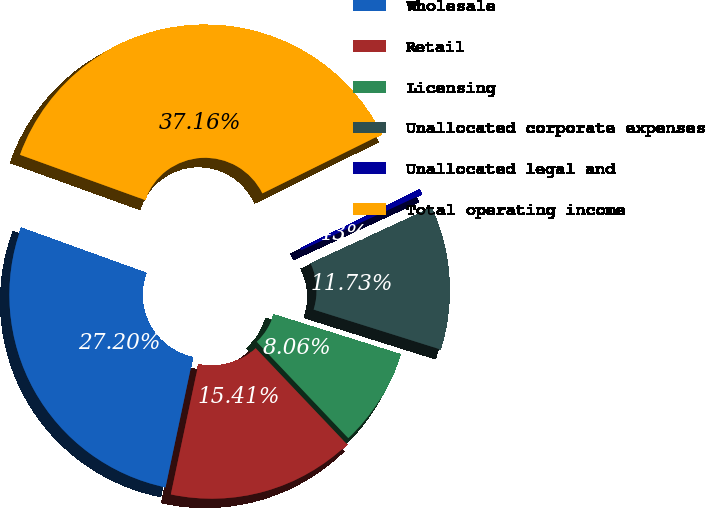Convert chart to OTSL. <chart><loc_0><loc_0><loc_500><loc_500><pie_chart><fcel>Wholesale<fcel>Retail<fcel>Licensing<fcel>Unallocated corporate expenses<fcel>Unallocated legal and<fcel>Total operating income<nl><fcel>27.2%<fcel>15.41%<fcel>8.06%<fcel>11.73%<fcel>0.43%<fcel>37.16%<nl></chart> 